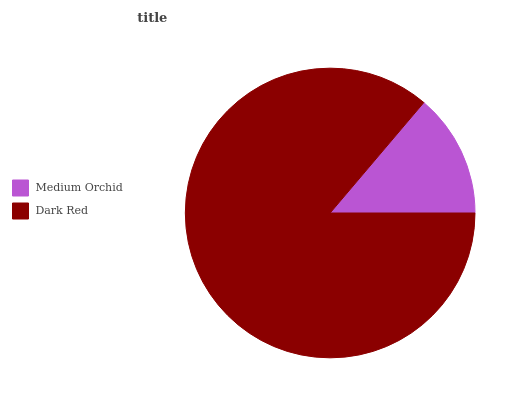Is Medium Orchid the minimum?
Answer yes or no. Yes. Is Dark Red the maximum?
Answer yes or no. Yes. Is Dark Red the minimum?
Answer yes or no. No. Is Dark Red greater than Medium Orchid?
Answer yes or no. Yes. Is Medium Orchid less than Dark Red?
Answer yes or no. Yes. Is Medium Orchid greater than Dark Red?
Answer yes or no. No. Is Dark Red less than Medium Orchid?
Answer yes or no. No. Is Dark Red the high median?
Answer yes or no. Yes. Is Medium Orchid the low median?
Answer yes or no. Yes. Is Medium Orchid the high median?
Answer yes or no. No. Is Dark Red the low median?
Answer yes or no. No. 